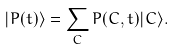Convert formula to latex. <formula><loc_0><loc_0><loc_500><loc_500>| P ( t ) \rangle = \sum _ { C } P ( C , t ) | C \rangle .</formula> 